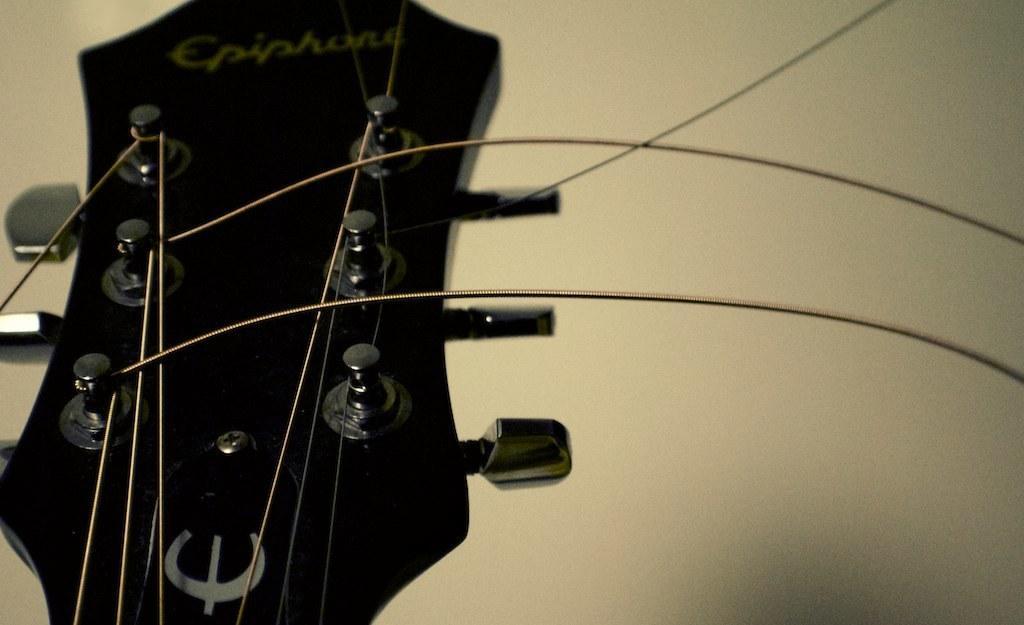Can you describe this image briefly? In the center of the image we can see guitar and strings. In the background there is wall. 